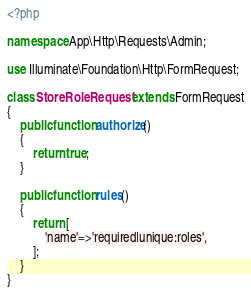Convert code to text. <code><loc_0><loc_0><loc_500><loc_500><_PHP_><?php

namespace App\Http\Requests\Admin;

use Illuminate\Foundation\Http\FormRequest;

class StoreRoleRequest extends FormRequest
{
    public function authorize()
    {
        return true;
    }
    
    public function rules()
    {
        return [
            'name'=>'required|unique:roles',
        ];
    }
}
</code> 